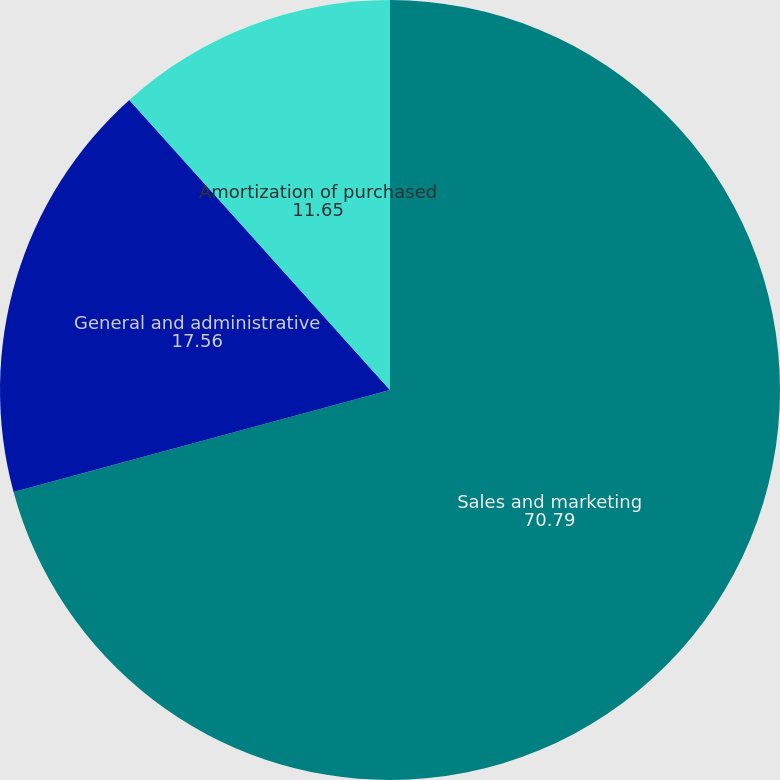Convert chart. <chart><loc_0><loc_0><loc_500><loc_500><pie_chart><fcel>Sales and marketing<fcel>General and administrative<fcel>Amortization of purchased<nl><fcel>70.79%<fcel>17.56%<fcel>11.65%<nl></chart> 